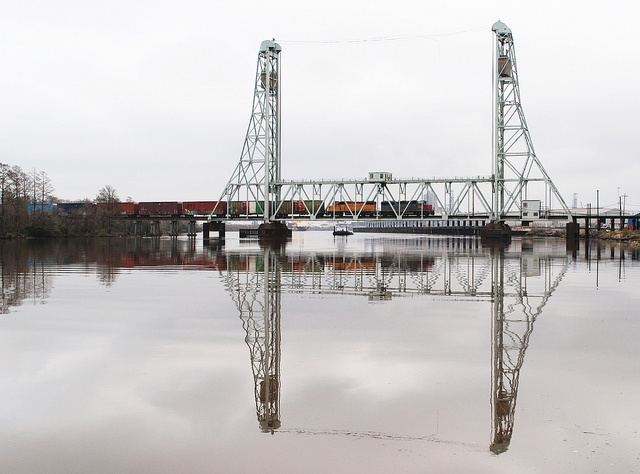Describe the objects in this image and their specific colors. I can see train in white, black, maroon, gray, and darkgray tones and boat in white, darkgray, lightgray, black, and gray tones in this image. 